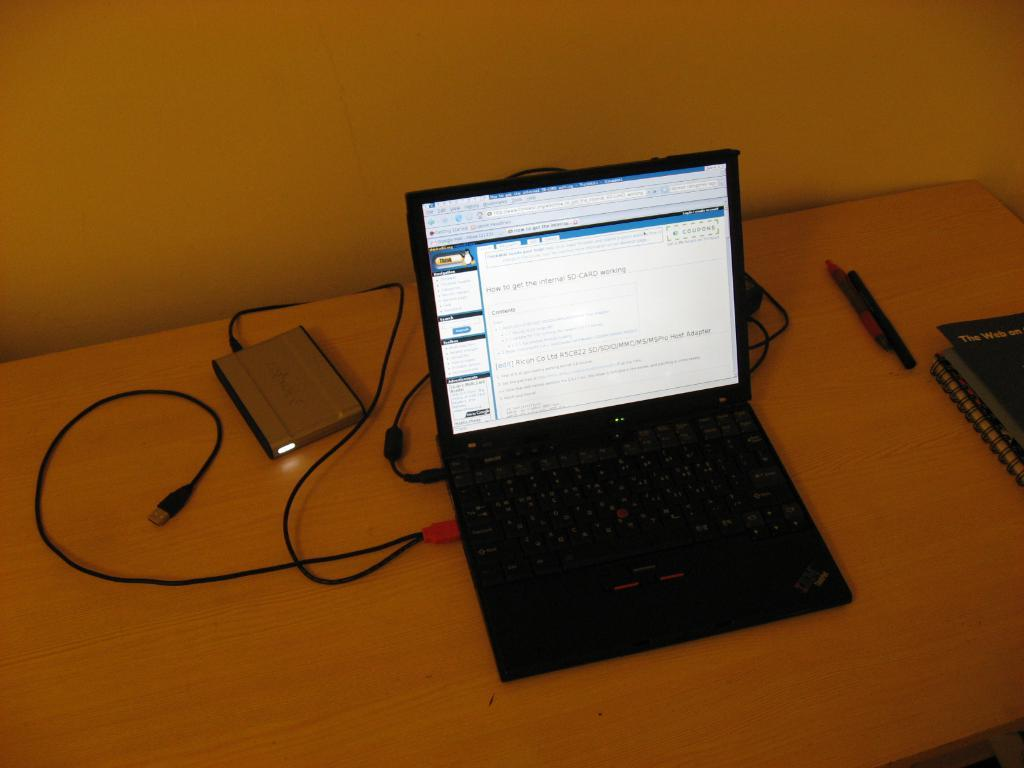What electronic device is visible in the image? There is a laptop in the image. What other items can be seen on the table in the image? There are books and pens visible in the image. Where are the laptop, books, and pens located? The laptop, books, and pens are on a table. What type of voice can be heard coming from the laptop in the image? There is no indication in the image that the laptop is producing any sound or voice. 